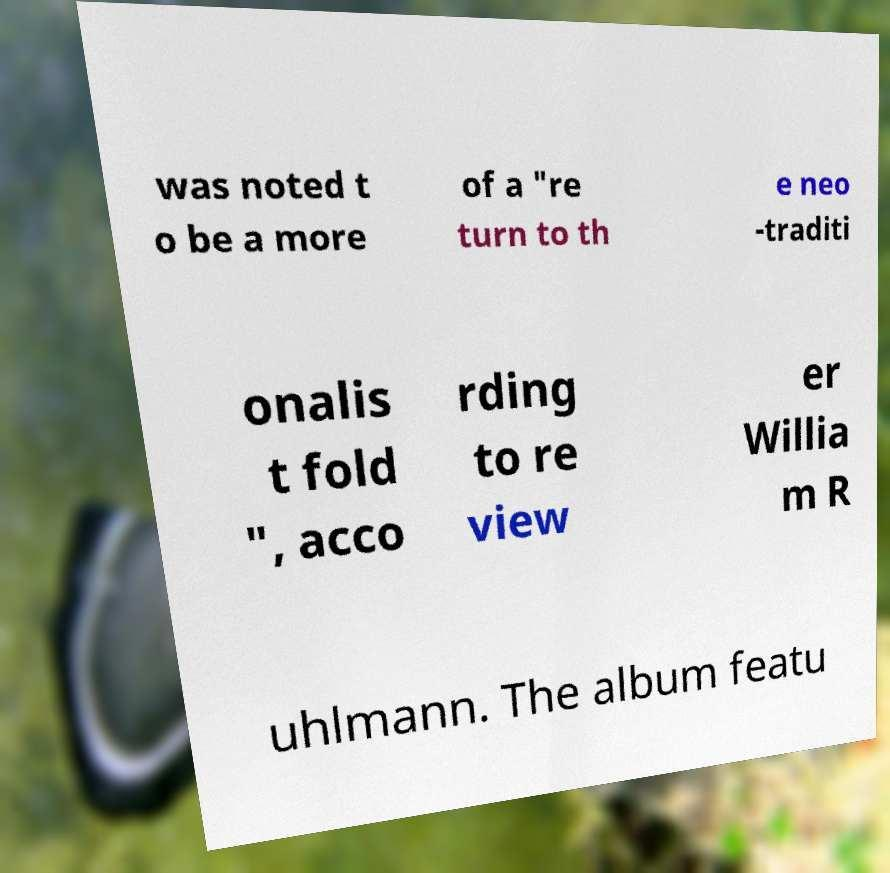Can you accurately transcribe the text from the provided image for me? was noted t o be a more of a "re turn to th e neo -traditi onalis t fold ", acco rding to re view er Willia m R uhlmann. The album featu 